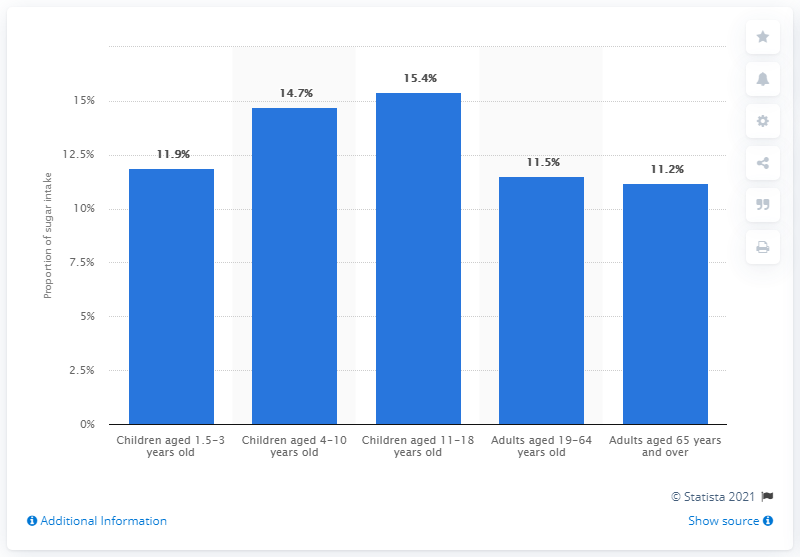Specify some key components in this picture. The dietary intake of sugar for children in the age bracket of 15.4 years was what was inquired. 